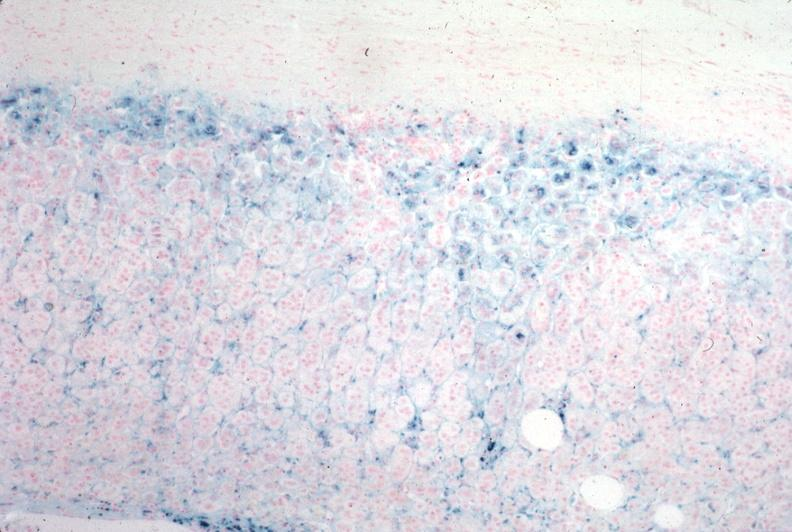does this image show iron stain?
Answer the question using a single word or phrase. Yes 